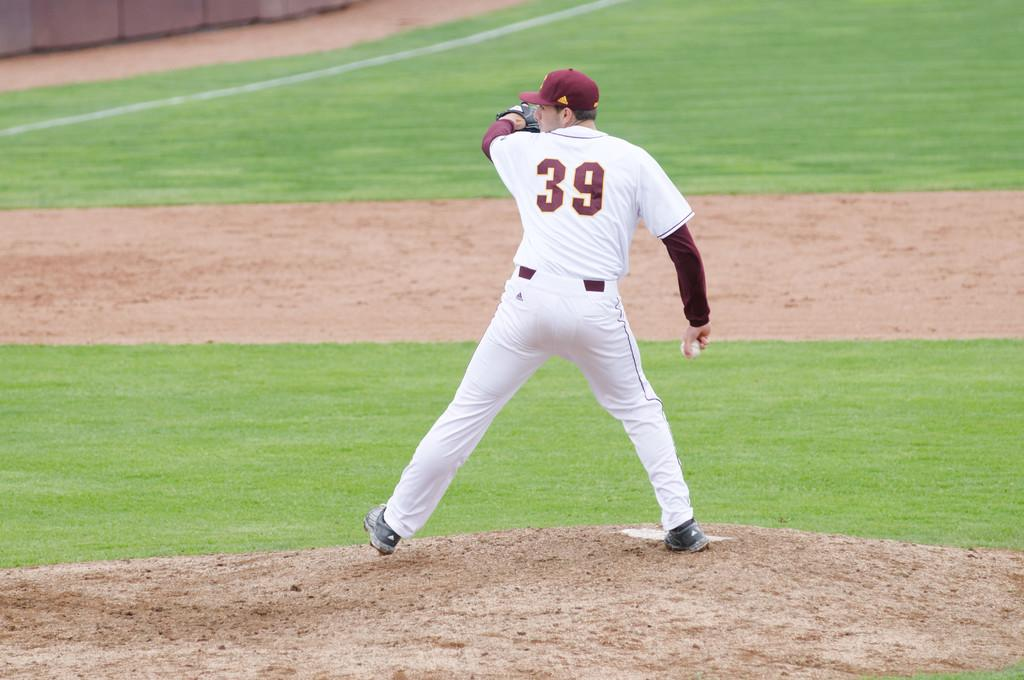<image>
Describe the image concisely. a man in a number 39 jersey about to pitch a ball 